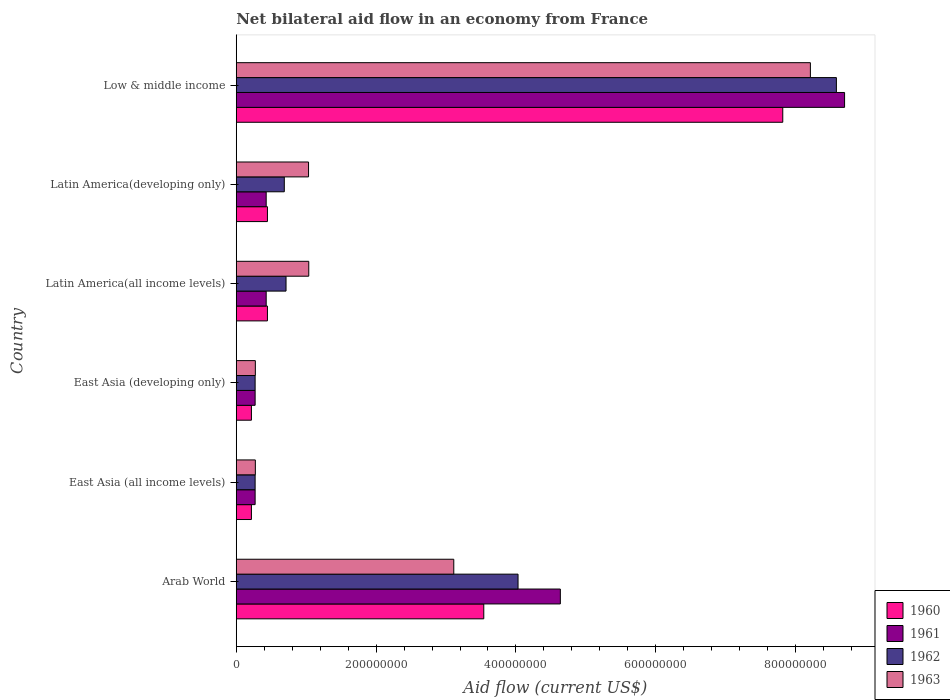How many different coloured bars are there?
Provide a short and direct response. 4. Are the number of bars per tick equal to the number of legend labels?
Provide a succinct answer. Yes. How many bars are there on the 6th tick from the bottom?
Offer a very short reply. 4. What is the label of the 5th group of bars from the top?
Give a very brief answer. East Asia (all income levels). What is the net bilateral aid flow in 1963 in Arab World?
Provide a short and direct response. 3.11e+08. Across all countries, what is the maximum net bilateral aid flow in 1961?
Keep it short and to the point. 8.70e+08. Across all countries, what is the minimum net bilateral aid flow in 1963?
Offer a very short reply. 2.73e+07. In which country was the net bilateral aid flow in 1963 minimum?
Provide a short and direct response. East Asia (all income levels). What is the total net bilateral aid flow in 1963 in the graph?
Your answer should be compact. 1.39e+09. What is the difference between the net bilateral aid flow in 1963 in Latin America(all income levels) and that in Latin America(developing only)?
Your answer should be very brief. 3.00e+05. What is the difference between the net bilateral aid flow in 1961 in Latin America(all income levels) and the net bilateral aid flow in 1960 in East Asia (all income levels)?
Your answer should be compact. 2.11e+07. What is the average net bilateral aid flow in 1962 per country?
Provide a short and direct response. 2.43e+08. What is the difference between the net bilateral aid flow in 1962 and net bilateral aid flow in 1963 in Latin America(developing only)?
Your response must be concise. -3.47e+07. In how many countries, is the net bilateral aid flow in 1961 greater than 520000000 US$?
Provide a short and direct response. 1. What is the ratio of the net bilateral aid flow in 1962 in East Asia (all income levels) to that in Latin America(developing only)?
Offer a terse response. 0.39. What is the difference between the highest and the second highest net bilateral aid flow in 1963?
Your response must be concise. 5.10e+08. What is the difference between the highest and the lowest net bilateral aid flow in 1963?
Offer a terse response. 7.94e+08. Is the sum of the net bilateral aid flow in 1961 in Latin America(developing only) and Low & middle income greater than the maximum net bilateral aid flow in 1960 across all countries?
Your response must be concise. Yes. What does the 3rd bar from the top in Arab World represents?
Provide a short and direct response. 1961. Is it the case that in every country, the sum of the net bilateral aid flow in 1960 and net bilateral aid flow in 1963 is greater than the net bilateral aid flow in 1962?
Offer a terse response. Yes. What is the difference between two consecutive major ticks on the X-axis?
Provide a succinct answer. 2.00e+08. Does the graph contain grids?
Your response must be concise. No. What is the title of the graph?
Your response must be concise. Net bilateral aid flow in an economy from France. Does "1966" appear as one of the legend labels in the graph?
Provide a succinct answer. No. What is the label or title of the Y-axis?
Your answer should be very brief. Country. What is the Aid flow (current US$) of 1960 in Arab World?
Give a very brief answer. 3.54e+08. What is the Aid flow (current US$) in 1961 in Arab World?
Keep it short and to the point. 4.64e+08. What is the Aid flow (current US$) in 1962 in Arab World?
Ensure brevity in your answer.  4.03e+08. What is the Aid flow (current US$) of 1963 in Arab World?
Offer a very short reply. 3.11e+08. What is the Aid flow (current US$) of 1960 in East Asia (all income levels)?
Give a very brief answer. 2.17e+07. What is the Aid flow (current US$) of 1961 in East Asia (all income levels)?
Give a very brief answer. 2.70e+07. What is the Aid flow (current US$) of 1962 in East Asia (all income levels)?
Ensure brevity in your answer.  2.70e+07. What is the Aid flow (current US$) of 1963 in East Asia (all income levels)?
Ensure brevity in your answer.  2.73e+07. What is the Aid flow (current US$) in 1960 in East Asia (developing only)?
Offer a terse response. 2.17e+07. What is the Aid flow (current US$) in 1961 in East Asia (developing only)?
Give a very brief answer. 2.70e+07. What is the Aid flow (current US$) of 1962 in East Asia (developing only)?
Your response must be concise. 2.70e+07. What is the Aid flow (current US$) of 1963 in East Asia (developing only)?
Ensure brevity in your answer.  2.73e+07. What is the Aid flow (current US$) in 1960 in Latin America(all income levels)?
Give a very brief answer. 4.46e+07. What is the Aid flow (current US$) in 1961 in Latin America(all income levels)?
Your response must be concise. 4.28e+07. What is the Aid flow (current US$) in 1962 in Latin America(all income levels)?
Keep it short and to the point. 7.12e+07. What is the Aid flow (current US$) of 1963 in Latin America(all income levels)?
Your answer should be compact. 1.04e+08. What is the Aid flow (current US$) of 1960 in Latin America(developing only)?
Your response must be concise. 4.46e+07. What is the Aid flow (current US$) of 1961 in Latin America(developing only)?
Provide a short and direct response. 4.28e+07. What is the Aid flow (current US$) in 1962 in Latin America(developing only)?
Provide a succinct answer. 6.87e+07. What is the Aid flow (current US$) in 1963 in Latin America(developing only)?
Offer a very short reply. 1.03e+08. What is the Aid flow (current US$) in 1960 in Low & middle income?
Your answer should be very brief. 7.82e+08. What is the Aid flow (current US$) of 1961 in Low & middle income?
Provide a succinct answer. 8.70e+08. What is the Aid flow (current US$) of 1962 in Low & middle income?
Make the answer very short. 8.58e+08. What is the Aid flow (current US$) of 1963 in Low & middle income?
Ensure brevity in your answer.  8.21e+08. Across all countries, what is the maximum Aid flow (current US$) of 1960?
Keep it short and to the point. 7.82e+08. Across all countries, what is the maximum Aid flow (current US$) in 1961?
Make the answer very short. 8.70e+08. Across all countries, what is the maximum Aid flow (current US$) in 1962?
Your response must be concise. 8.58e+08. Across all countries, what is the maximum Aid flow (current US$) in 1963?
Provide a succinct answer. 8.21e+08. Across all countries, what is the minimum Aid flow (current US$) of 1960?
Offer a very short reply. 2.17e+07. Across all countries, what is the minimum Aid flow (current US$) of 1961?
Your answer should be compact. 2.70e+07. Across all countries, what is the minimum Aid flow (current US$) in 1962?
Give a very brief answer. 2.70e+07. Across all countries, what is the minimum Aid flow (current US$) in 1963?
Provide a succinct answer. 2.73e+07. What is the total Aid flow (current US$) of 1960 in the graph?
Your answer should be very brief. 1.27e+09. What is the total Aid flow (current US$) in 1961 in the graph?
Offer a terse response. 1.47e+09. What is the total Aid flow (current US$) of 1962 in the graph?
Give a very brief answer. 1.46e+09. What is the total Aid flow (current US$) in 1963 in the graph?
Offer a very short reply. 1.39e+09. What is the difference between the Aid flow (current US$) in 1960 in Arab World and that in East Asia (all income levels)?
Offer a terse response. 3.32e+08. What is the difference between the Aid flow (current US$) in 1961 in Arab World and that in East Asia (all income levels)?
Provide a succinct answer. 4.36e+08. What is the difference between the Aid flow (current US$) in 1962 in Arab World and that in East Asia (all income levels)?
Offer a very short reply. 3.76e+08. What is the difference between the Aid flow (current US$) of 1963 in Arab World and that in East Asia (all income levels)?
Your answer should be compact. 2.84e+08. What is the difference between the Aid flow (current US$) of 1960 in Arab World and that in East Asia (developing only)?
Give a very brief answer. 3.32e+08. What is the difference between the Aid flow (current US$) in 1961 in Arab World and that in East Asia (developing only)?
Offer a very short reply. 4.36e+08. What is the difference between the Aid flow (current US$) of 1962 in Arab World and that in East Asia (developing only)?
Your answer should be very brief. 3.76e+08. What is the difference between the Aid flow (current US$) in 1963 in Arab World and that in East Asia (developing only)?
Ensure brevity in your answer.  2.84e+08. What is the difference between the Aid flow (current US$) in 1960 in Arab World and that in Latin America(all income levels)?
Your answer should be compact. 3.09e+08. What is the difference between the Aid flow (current US$) of 1961 in Arab World and that in Latin America(all income levels)?
Offer a very short reply. 4.21e+08. What is the difference between the Aid flow (current US$) in 1962 in Arab World and that in Latin America(all income levels)?
Your answer should be very brief. 3.32e+08. What is the difference between the Aid flow (current US$) of 1963 in Arab World and that in Latin America(all income levels)?
Make the answer very short. 2.07e+08. What is the difference between the Aid flow (current US$) of 1960 in Arab World and that in Latin America(developing only)?
Your response must be concise. 3.09e+08. What is the difference between the Aid flow (current US$) in 1961 in Arab World and that in Latin America(developing only)?
Make the answer very short. 4.21e+08. What is the difference between the Aid flow (current US$) of 1962 in Arab World and that in Latin America(developing only)?
Provide a short and direct response. 3.34e+08. What is the difference between the Aid flow (current US$) in 1963 in Arab World and that in Latin America(developing only)?
Provide a short and direct response. 2.08e+08. What is the difference between the Aid flow (current US$) of 1960 in Arab World and that in Low & middle income?
Give a very brief answer. -4.28e+08. What is the difference between the Aid flow (current US$) of 1961 in Arab World and that in Low & middle income?
Your answer should be very brief. -4.06e+08. What is the difference between the Aid flow (current US$) of 1962 in Arab World and that in Low & middle income?
Your response must be concise. -4.55e+08. What is the difference between the Aid flow (current US$) of 1963 in Arab World and that in Low & middle income?
Make the answer very short. -5.10e+08. What is the difference between the Aid flow (current US$) of 1961 in East Asia (all income levels) and that in East Asia (developing only)?
Ensure brevity in your answer.  0. What is the difference between the Aid flow (current US$) of 1962 in East Asia (all income levels) and that in East Asia (developing only)?
Make the answer very short. 0. What is the difference between the Aid flow (current US$) of 1960 in East Asia (all income levels) and that in Latin America(all income levels)?
Ensure brevity in your answer.  -2.29e+07. What is the difference between the Aid flow (current US$) of 1961 in East Asia (all income levels) and that in Latin America(all income levels)?
Offer a very short reply. -1.58e+07. What is the difference between the Aid flow (current US$) in 1962 in East Asia (all income levels) and that in Latin America(all income levels)?
Provide a short and direct response. -4.42e+07. What is the difference between the Aid flow (current US$) of 1963 in East Asia (all income levels) and that in Latin America(all income levels)?
Ensure brevity in your answer.  -7.64e+07. What is the difference between the Aid flow (current US$) in 1960 in East Asia (all income levels) and that in Latin America(developing only)?
Give a very brief answer. -2.29e+07. What is the difference between the Aid flow (current US$) in 1961 in East Asia (all income levels) and that in Latin America(developing only)?
Make the answer very short. -1.58e+07. What is the difference between the Aid flow (current US$) of 1962 in East Asia (all income levels) and that in Latin America(developing only)?
Ensure brevity in your answer.  -4.17e+07. What is the difference between the Aid flow (current US$) of 1963 in East Asia (all income levels) and that in Latin America(developing only)?
Provide a short and direct response. -7.61e+07. What is the difference between the Aid flow (current US$) in 1960 in East Asia (all income levels) and that in Low & middle income?
Your response must be concise. -7.60e+08. What is the difference between the Aid flow (current US$) in 1961 in East Asia (all income levels) and that in Low & middle income?
Your answer should be very brief. -8.43e+08. What is the difference between the Aid flow (current US$) in 1962 in East Asia (all income levels) and that in Low & middle income?
Give a very brief answer. -8.31e+08. What is the difference between the Aid flow (current US$) of 1963 in East Asia (all income levels) and that in Low & middle income?
Provide a short and direct response. -7.94e+08. What is the difference between the Aid flow (current US$) in 1960 in East Asia (developing only) and that in Latin America(all income levels)?
Your answer should be very brief. -2.29e+07. What is the difference between the Aid flow (current US$) of 1961 in East Asia (developing only) and that in Latin America(all income levels)?
Make the answer very short. -1.58e+07. What is the difference between the Aid flow (current US$) of 1962 in East Asia (developing only) and that in Latin America(all income levels)?
Offer a terse response. -4.42e+07. What is the difference between the Aid flow (current US$) in 1963 in East Asia (developing only) and that in Latin America(all income levels)?
Your answer should be very brief. -7.64e+07. What is the difference between the Aid flow (current US$) in 1960 in East Asia (developing only) and that in Latin America(developing only)?
Provide a succinct answer. -2.29e+07. What is the difference between the Aid flow (current US$) in 1961 in East Asia (developing only) and that in Latin America(developing only)?
Provide a short and direct response. -1.58e+07. What is the difference between the Aid flow (current US$) in 1962 in East Asia (developing only) and that in Latin America(developing only)?
Ensure brevity in your answer.  -4.17e+07. What is the difference between the Aid flow (current US$) in 1963 in East Asia (developing only) and that in Latin America(developing only)?
Your answer should be very brief. -7.61e+07. What is the difference between the Aid flow (current US$) of 1960 in East Asia (developing only) and that in Low & middle income?
Keep it short and to the point. -7.60e+08. What is the difference between the Aid flow (current US$) of 1961 in East Asia (developing only) and that in Low & middle income?
Offer a terse response. -8.43e+08. What is the difference between the Aid flow (current US$) in 1962 in East Asia (developing only) and that in Low & middle income?
Your answer should be very brief. -8.31e+08. What is the difference between the Aid flow (current US$) of 1963 in East Asia (developing only) and that in Low & middle income?
Make the answer very short. -7.94e+08. What is the difference between the Aid flow (current US$) of 1960 in Latin America(all income levels) and that in Latin America(developing only)?
Your answer should be very brief. 0. What is the difference between the Aid flow (current US$) of 1962 in Latin America(all income levels) and that in Latin America(developing only)?
Provide a short and direct response. 2.50e+06. What is the difference between the Aid flow (current US$) in 1960 in Latin America(all income levels) and that in Low & middle income?
Ensure brevity in your answer.  -7.37e+08. What is the difference between the Aid flow (current US$) in 1961 in Latin America(all income levels) and that in Low & middle income?
Your answer should be very brief. -8.27e+08. What is the difference between the Aid flow (current US$) of 1962 in Latin America(all income levels) and that in Low & middle income?
Offer a very short reply. -7.87e+08. What is the difference between the Aid flow (current US$) of 1963 in Latin America(all income levels) and that in Low & middle income?
Give a very brief answer. -7.17e+08. What is the difference between the Aid flow (current US$) in 1960 in Latin America(developing only) and that in Low & middle income?
Your response must be concise. -7.37e+08. What is the difference between the Aid flow (current US$) in 1961 in Latin America(developing only) and that in Low & middle income?
Offer a terse response. -8.27e+08. What is the difference between the Aid flow (current US$) of 1962 in Latin America(developing only) and that in Low & middle income?
Make the answer very short. -7.90e+08. What is the difference between the Aid flow (current US$) of 1963 in Latin America(developing only) and that in Low & middle income?
Offer a terse response. -7.18e+08. What is the difference between the Aid flow (current US$) in 1960 in Arab World and the Aid flow (current US$) in 1961 in East Asia (all income levels)?
Make the answer very short. 3.27e+08. What is the difference between the Aid flow (current US$) of 1960 in Arab World and the Aid flow (current US$) of 1962 in East Asia (all income levels)?
Offer a terse response. 3.27e+08. What is the difference between the Aid flow (current US$) in 1960 in Arab World and the Aid flow (current US$) in 1963 in East Asia (all income levels)?
Offer a terse response. 3.27e+08. What is the difference between the Aid flow (current US$) in 1961 in Arab World and the Aid flow (current US$) in 1962 in East Asia (all income levels)?
Your response must be concise. 4.36e+08. What is the difference between the Aid flow (current US$) in 1961 in Arab World and the Aid flow (current US$) in 1963 in East Asia (all income levels)?
Your response must be concise. 4.36e+08. What is the difference between the Aid flow (current US$) in 1962 in Arab World and the Aid flow (current US$) in 1963 in East Asia (all income levels)?
Your response must be concise. 3.76e+08. What is the difference between the Aid flow (current US$) of 1960 in Arab World and the Aid flow (current US$) of 1961 in East Asia (developing only)?
Provide a short and direct response. 3.27e+08. What is the difference between the Aid flow (current US$) in 1960 in Arab World and the Aid flow (current US$) in 1962 in East Asia (developing only)?
Provide a short and direct response. 3.27e+08. What is the difference between the Aid flow (current US$) of 1960 in Arab World and the Aid flow (current US$) of 1963 in East Asia (developing only)?
Give a very brief answer. 3.27e+08. What is the difference between the Aid flow (current US$) in 1961 in Arab World and the Aid flow (current US$) in 1962 in East Asia (developing only)?
Offer a terse response. 4.36e+08. What is the difference between the Aid flow (current US$) of 1961 in Arab World and the Aid flow (current US$) of 1963 in East Asia (developing only)?
Offer a terse response. 4.36e+08. What is the difference between the Aid flow (current US$) of 1962 in Arab World and the Aid flow (current US$) of 1963 in East Asia (developing only)?
Provide a succinct answer. 3.76e+08. What is the difference between the Aid flow (current US$) of 1960 in Arab World and the Aid flow (current US$) of 1961 in Latin America(all income levels)?
Provide a succinct answer. 3.11e+08. What is the difference between the Aid flow (current US$) in 1960 in Arab World and the Aid flow (current US$) in 1962 in Latin America(all income levels)?
Ensure brevity in your answer.  2.83e+08. What is the difference between the Aid flow (current US$) of 1960 in Arab World and the Aid flow (current US$) of 1963 in Latin America(all income levels)?
Ensure brevity in your answer.  2.50e+08. What is the difference between the Aid flow (current US$) in 1961 in Arab World and the Aid flow (current US$) in 1962 in Latin America(all income levels)?
Make the answer very short. 3.92e+08. What is the difference between the Aid flow (current US$) of 1961 in Arab World and the Aid flow (current US$) of 1963 in Latin America(all income levels)?
Offer a very short reply. 3.60e+08. What is the difference between the Aid flow (current US$) of 1962 in Arab World and the Aid flow (current US$) of 1963 in Latin America(all income levels)?
Your answer should be very brief. 2.99e+08. What is the difference between the Aid flow (current US$) in 1960 in Arab World and the Aid flow (current US$) in 1961 in Latin America(developing only)?
Your response must be concise. 3.11e+08. What is the difference between the Aid flow (current US$) in 1960 in Arab World and the Aid flow (current US$) in 1962 in Latin America(developing only)?
Give a very brief answer. 2.85e+08. What is the difference between the Aid flow (current US$) in 1960 in Arab World and the Aid flow (current US$) in 1963 in Latin America(developing only)?
Your answer should be compact. 2.51e+08. What is the difference between the Aid flow (current US$) in 1961 in Arab World and the Aid flow (current US$) in 1962 in Latin America(developing only)?
Your response must be concise. 3.95e+08. What is the difference between the Aid flow (current US$) in 1961 in Arab World and the Aid flow (current US$) in 1963 in Latin America(developing only)?
Keep it short and to the point. 3.60e+08. What is the difference between the Aid flow (current US$) of 1962 in Arab World and the Aid flow (current US$) of 1963 in Latin America(developing only)?
Ensure brevity in your answer.  3.00e+08. What is the difference between the Aid flow (current US$) of 1960 in Arab World and the Aid flow (current US$) of 1961 in Low & middle income?
Keep it short and to the point. -5.16e+08. What is the difference between the Aid flow (current US$) in 1960 in Arab World and the Aid flow (current US$) in 1962 in Low & middle income?
Your response must be concise. -5.04e+08. What is the difference between the Aid flow (current US$) in 1960 in Arab World and the Aid flow (current US$) in 1963 in Low & middle income?
Your answer should be compact. -4.67e+08. What is the difference between the Aid flow (current US$) of 1961 in Arab World and the Aid flow (current US$) of 1962 in Low & middle income?
Give a very brief answer. -3.95e+08. What is the difference between the Aid flow (current US$) of 1961 in Arab World and the Aid flow (current US$) of 1963 in Low & middle income?
Keep it short and to the point. -3.58e+08. What is the difference between the Aid flow (current US$) of 1962 in Arab World and the Aid flow (current US$) of 1963 in Low & middle income?
Provide a succinct answer. -4.18e+08. What is the difference between the Aid flow (current US$) in 1960 in East Asia (all income levels) and the Aid flow (current US$) in 1961 in East Asia (developing only)?
Ensure brevity in your answer.  -5.30e+06. What is the difference between the Aid flow (current US$) of 1960 in East Asia (all income levels) and the Aid flow (current US$) of 1962 in East Asia (developing only)?
Ensure brevity in your answer.  -5.30e+06. What is the difference between the Aid flow (current US$) of 1960 in East Asia (all income levels) and the Aid flow (current US$) of 1963 in East Asia (developing only)?
Keep it short and to the point. -5.60e+06. What is the difference between the Aid flow (current US$) in 1962 in East Asia (all income levels) and the Aid flow (current US$) in 1963 in East Asia (developing only)?
Keep it short and to the point. -3.00e+05. What is the difference between the Aid flow (current US$) in 1960 in East Asia (all income levels) and the Aid flow (current US$) in 1961 in Latin America(all income levels)?
Your answer should be very brief. -2.11e+07. What is the difference between the Aid flow (current US$) in 1960 in East Asia (all income levels) and the Aid flow (current US$) in 1962 in Latin America(all income levels)?
Your response must be concise. -4.95e+07. What is the difference between the Aid flow (current US$) in 1960 in East Asia (all income levels) and the Aid flow (current US$) in 1963 in Latin America(all income levels)?
Ensure brevity in your answer.  -8.20e+07. What is the difference between the Aid flow (current US$) in 1961 in East Asia (all income levels) and the Aid flow (current US$) in 1962 in Latin America(all income levels)?
Ensure brevity in your answer.  -4.42e+07. What is the difference between the Aid flow (current US$) in 1961 in East Asia (all income levels) and the Aid flow (current US$) in 1963 in Latin America(all income levels)?
Ensure brevity in your answer.  -7.67e+07. What is the difference between the Aid flow (current US$) of 1962 in East Asia (all income levels) and the Aid flow (current US$) of 1963 in Latin America(all income levels)?
Make the answer very short. -7.67e+07. What is the difference between the Aid flow (current US$) of 1960 in East Asia (all income levels) and the Aid flow (current US$) of 1961 in Latin America(developing only)?
Ensure brevity in your answer.  -2.11e+07. What is the difference between the Aid flow (current US$) of 1960 in East Asia (all income levels) and the Aid flow (current US$) of 1962 in Latin America(developing only)?
Your answer should be very brief. -4.70e+07. What is the difference between the Aid flow (current US$) of 1960 in East Asia (all income levels) and the Aid flow (current US$) of 1963 in Latin America(developing only)?
Your response must be concise. -8.17e+07. What is the difference between the Aid flow (current US$) in 1961 in East Asia (all income levels) and the Aid flow (current US$) in 1962 in Latin America(developing only)?
Keep it short and to the point. -4.17e+07. What is the difference between the Aid flow (current US$) in 1961 in East Asia (all income levels) and the Aid flow (current US$) in 1963 in Latin America(developing only)?
Keep it short and to the point. -7.64e+07. What is the difference between the Aid flow (current US$) in 1962 in East Asia (all income levels) and the Aid flow (current US$) in 1963 in Latin America(developing only)?
Give a very brief answer. -7.64e+07. What is the difference between the Aid flow (current US$) in 1960 in East Asia (all income levels) and the Aid flow (current US$) in 1961 in Low & middle income?
Provide a succinct answer. -8.48e+08. What is the difference between the Aid flow (current US$) in 1960 in East Asia (all income levels) and the Aid flow (current US$) in 1962 in Low & middle income?
Offer a very short reply. -8.37e+08. What is the difference between the Aid flow (current US$) of 1960 in East Asia (all income levels) and the Aid flow (current US$) of 1963 in Low & middle income?
Ensure brevity in your answer.  -7.99e+08. What is the difference between the Aid flow (current US$) in 1961 in East Asia (all income levels) and the Aid flow (current US$) in 1962 in Low & middle income?
Your response must be concise. -8.31e+08. What is the difference between the Aid flow (current US$) in 1961 in East Asia (all income levels) and the Aid flow (current US$) in 1963 in Low & middle income?
Your response must be concise. -7.94e+08. What is the difference between the Aid flow (current US$) of 1962 in East Asia (all income levels) and the Aid flow (current US$) of 1963 in Low & middle income?
Offer a very short reply. -7.94e+08. What is the difference between the Aid flow (current US$) of 1960 in East Asia (developing only) and the Aid flow (current US$) of 1961 in Latin America(all income levels)?
Make the answer very short. -2.11e+07. What is the difference between the Aid flow (current US$) in 1960 in East Asia (developing only) and the Aid flow (current US$) in 1962 in Latin America(all income levels)?
Provide a short and direct response. -4.95e+07. What is the difference between the Aid flow (current US$) of 1960 in East Asia (developing only) and the Aid flow (current US$) of 1963 in Latin America(all income levels)?
Offer a very short reply. -8.20e+07. What is the difference between the Aid flow (current US$) of 1961 in East Asia (developing only) and the Aid flow (current US$) of 1962 in Latin America(all income levels)?
Offer a terse response. -4.42e+07. What is the difference between the Aid flow (current US$) in 1961 in East Asia (developing only) and the Aid flow (current US$) in 1963 in Latin America(all income levels)?
Your response must be concise. -7.67e+07. What is the difference between the Aid flow (current US$) in 1962 in East Asia (developing only) and the Aid flow (current US$) in 1963 in Latin America(all income levels)?
Provide a succinct answer. -7.67e+07. What is the difference between the Aid flow (current US$) in 1960 in East Asia (developing only) and the Aid flow (current US$) in 1961 in Latin America(developing only)?
Your answer should be very brief. -2.11e+07. What is the difference between the Aid flow (current US$) of 1960 in East Asia (developing only) and the Aid flow (current US$) of 1962 in Latin America(developing only)?
Provide a short and direct response. -4.70e+07. What is the difference between the Aid flow (current US$) in 1960 in East Asia (developing only) and the Aid flow (current US$) in 1963 in Latin America(developing only)?
Provide a short and direct response. -8.17e+07. What is the difference between the Aid flow (current US$) in 1961 in East Asia (developing only) and the Aid flow (current US$) in 1962 in Latin America(developing only)?
Provide a succinct answer. -4.17e+07. What is the difference between the Aid flow (current US$) in 1961 in East Asia (developing only) and the Aid flow (current US$) in 1963 in Latin America(developing only)?
Give a very brief answer. -7.64e+07. What is the difference between the Aid flow (current US$) of 1962 in East Asia (developing only) and the Aid flow (current US$) of 1963 in Latin America(developing only)?
Your answer should be compact. -7.64e+07. What is the difference between the Aid flow (current US$) in 1960 in East Asia (developing only) and the Aid flow (current US$) in 1961 in Low & middle income?
Provide a succinct answer. -8.48e+08. What is the difference between the Aid flow (current US$) of 1960 in East Asia (developing only) and the Aid flow (current US$) of 1962 in Low & middle income?
Offer a very short reply. -8.37e+08. What is the difference between the Aid flow (current US$) in 1960 in East Asia (developing only) and the Aid flow (current US$) in 1963 in Low & middle income?
Provide a short and direct response. -7.99e+08. What is the difference between the Aid flow (current US$) in 1961 in East Asia (developing only) and the Aid flow (current US$) in 1962 in Low & middle income?
Offer a terse response. -8.31e+08. What is the difference between the Aid flow (current US$) of 1961 in East Asia (developing only) and the Aid flow (current US$) of 1963 in Low & middle income?
Give a very brief answer. -7.94e+08. What is the difference between the Aid flow (current US$) in 1962 in East Asia (developing only) and the Aid flow (current US$) in 1963 in Low & middle income?
Make the answer very short. -7.94e+08. What is the difference between the Aid flow (current US$) of 1960 in Latin America(all income levels) and the Aid flow (current US$) of 1961 in Latin America(developing only)?
Give a very brief answer. 1.80e+06. What is the difference between the Aid flow (current US$) of 1960 in Latin America(all income levels) and the Aid flow (current US$) of 1962 in Latin America(developing only)?
Give a very brief answer. -2.41e+07. What is the difference between the Aid flow (current US$) of 1960 in Latin America(all income levels) and the Aid flow (current US$) of 1963 in Latin America(developing only)?
Offer a terse response. -5.88e+07. What is the difference between the Aid flow (current US$) of 1961 in Latin America(all income levels) and the Aid flow (current US$) of 1962 in Latin America(developing only)?
Offer a terse response. -2.59e+07. What is the difference between the Aid flow (current US$) in 1961 in Latin America(all income levels) and the Aid flow (current US$) in 1963 in Latin America(developing only)?
Your response must be concise. -6.06e+07. What is the difference between the Aid flow (current US$) of 1962 in Latin America(all income levels) and the Aid flow (current US$) of 1963 in Latin America(developing only)?
Ensure brevity in your answer.  -3.22e+07. What is the difference between the Aid flow (current US$) in 1960 in Latin America(all income levels) and the Aid flow (current US$) in 1961 in Low & middle income?
Keep it short and to the point. -8.25e+08. What is the difference between the Aid flow (current US$) of 1960 in Latin America(all income levels) and the Aid flow (current US$) of 1962 in Low & middle income?
Keep it short and to the point. -8.14e+08. What is the difference between the Aid flow (current US$) of 1960 in Latin America(all income levels) and the Aid flow (current US$) of 1963 in Low & middle income?
Provide a succinct answer. -7.76e+08. What is the difference between the Aid flow (current US$) in 1961 in Latin America(all income levels) and the Aid flow (current US$) in 1962 in Low & middle income?
Your answer should be compact. -8.16e+08. What is the difference between the Aid flow (current US$) of 1961 in Latin America(all income levels) and the Aid flow (current US$) of 1963 in Low & middle income?
Make the answer very short. -7.78e+08. What is the difference between the Aid flow (current US$) of 1962 in Latin America(all income levels) and the Aid flow (current US$) of 1963 in Low & middle income?
Provide a succinct answer. -7.50e+08. What is the difference between the Aid flow (current US$) of 1960 in Latin America(developing only) and the Aid flow (current US$) of 1961 in Low & middle income?
Provide a succinct answer. -8.25e+08. What is the difference between the Aid flow (current US$) in 1960 in Latin America(developing only) and the Aid flow (current US$) in 1962 in Low & middle income?
Keep it short and to the point. -8.14e+08. What is the difference between the Aid flow (current US$) of 1960 in Latin America(developing only) and the Aid flow (current US$) of 1963 in Low & middle income?
Offer a very short reply. -7.76e+08. What is the difference between the Aid flow (current US$) of 1961 in Latin America(developing only) and the Aid flow (current US$) of 1962 in Low & middle income?
Provide a succinct answer. -8.16e+08. What is the difference between the Aid flow (current US$) of 1961 in Latin America(developing only) and the Aid flow (current US$) of 1963 in Low & middle income?
Offer a very short reply. -7.78e+08. What is the difference between the Aid flow (current US$) of 1962 in Latin America(developing only) and the Aid flow (current US$) of 1963 in Low & middle income?
Your response must be concise. -7.52e+08. What is the average Aid flow (current US$) of 1960 per country?
Your response must be concise. 2.11e+08. What is the average Aid flow (current US$) of 1961 per country?
Your answer should be compact. 2.46e+08. What is the average Aid flow (current US$) of 1962 per country?
Ensure brevity in your answer.  2.43e+08. What is the average Aid flow (current US$) of 1963 per country?
Make the answer very short. 2.32e+08. What is the difference between the Aid flow (current US$) in 1960 and Aid flow (current US$) in 1961 in Arab World?
Your response must be concise. -1.10e+08. What is the difference between the Aid flow (current US$) in 1960 and Aid flow (current US$) in 1962 in Arab World?
Provide a succinct answer. -4.90e+07. What is the difference between the Aid flow (current US$) of 1960 and Aid flow (current US$) of 1963 in Arab World?
Your answer should be very brief. 4.29e+07. What is the difference between the Aid flow (current US$) in 1961 and Aid flow (current US$) in 1962 in Arab World?
Ensure brevity in your answer.  6.05e+07. What is the difference between the Aid flow (current US$) in 1961 and Aid flow (current US$) in 1963 in Arab World?
Make the answer very short. 1.52e+08. What is the difference between the Aid flow (current US$) in 1962 and Aid flow (current US$) in 1963 in Arab World?
Your answer should be compact. 9.19e+07. What is the difference between the Aid flow (current US$) of 1960 and Aid flow (current US$) of 1961 in East Asia (all income levels)?
Offer a very short reply. -5.30e+06. What is the difference between the Aid flow (current US$) in 1960 and Aid flow (current US$) in 1962 in East Asia (all income levels)?
Offer a terse response. -5.30e+06. What is the difference between the Aid flow (current US$) in 1960 and Aid flow (current US$) in 1963 in East Asia (all income levels)?
Give a very brief answer. -5.60e+06. What is the difference between the Aid flow (current US$) of 1961 and Aid flow (current US$) of 1962 in East Asia (all income levels)?
Provide a short and direct response. 0. What is the difference between the Aid flow (current US$) in 1961 and Aid flow (current US$) in 1963 in East Asia (all income levels)?
Offer a very short reply. -3.00e+05. What is the difference between the Aid flow (current US$) of 1962 and Aid flow (current US$) of 1963 in East Asia (all income levels)?
Your answer should be very brief. -3.00e+05. What is the difference between the Aid flow (current US$) of 1960 and Aid flow (current US$) of 1961 in East Asia (developing only)?
Your response must be concise. -5.30e+06. What is the difference between the Aid flow (current US$) of 1960 and Aid flow (current US$) of 1962 in East Asia (developing only)?
Offer a terse response. -5.30e+06. What is the difference between the Aid flow (current US$) of 1960 and Aid flow (current US$) of 1963 in East Asia (developing only)?
Your answer should be very brief. -5.60e+06. What is the difference between the Aid flow (current US$) of 1961 and Aid flow (current US$) of 1963 in East Asia (developing only)?
Offer a very short reply. -3.00e+05. What is the difference between the Aid flow (current US$) in 1962 and Aid flow (current US$) in 1963 in East Asia (developing only)?
Ensure brevity in your answer.  -3.00e+05. What is the difference between the Aid flow (current US$) in 1960 and Aid flow (current US$) in 1961 in Latin America(all income levels)?
Keep it short and to the point. 1.80e+06. What is the difference between the Aid flow (current US$) in 1960 and Aid flow (current US$) in 1962 in Latin America(all income levels)?
Offer a very short reply. -2.66e+07. What is the difference between the Aid flow (current US$) of 1960 and Aid flow (current US$) of 1963 in Latin America(all income levels)?
Your answer should be very brief. -5.91e+07. What is the difference between the Aid flow (current US$) of 1961 and Aid flow (current US$) of 1962 in Latin America(all income levels)?
Provide a short and direct response. -2.84e+07. What is the difference between the Aid flow (current US$) in 1961 and Aid flow (current US$) in 1963 in Latin America(all income levels)?
Keep it short and to the point. -6.09e+07. What is the difference between the Aid flow (current US$) of 1962 and Aid flow (current US$) of 1963 in Latin America(all income levels)?
Give a very brief answer. -3.25e+07. What is the difference between the Aid flow (current US$) in 1960 and Aid flow (current US$) in 1961 in Latin America(developing only)?
Make the answer very short. 1.80e+06. What is the difference between the Aid flow (current US$) in 1960 and Aid flow (current US$) in 1962 in Latin America(developing only)?
Give a very brief answer. -2.41e+07. What is the difference between the Aid flow (current US$) in 1960 and Aid flow (current US$) in 1963 in Latin America(developing only)?
Ensure brevity in your answer.  -5.88e+07. What is the difference between the Aid flow (current US$) in 1961 and Aid flow (current US$) in 1962 in Latin America(developing only)?
Your answer should be very brief. -2.59e+07. What is the difference between the Aid flow (current US$) of 1961 and Aid flow (current US$) of 1963 in Latin America(developing only)?
Give a very brief answer. -6.06e+07. What is the difference between the Aid flow (current US$) in 1962 and Aid flow (current US$) in 1963 in Latin America(developing only)?
Your answer should be compact. -3.47e+07. What is the difference between the Aid flow (current US$) of 1960 and Aid flow (current US$) of 1961 in Low & middle income?
Your answer should be very brief. -8.84e+07. What is the difference between the Aid flow (current US$) in 1960 and Aid flow (current US$) in 1962 in Low & middle income?
Make the answer very short. -7.67e+07. What is the difference between the Aid flow (current US$) of 1960 and Aid flow (current US$) of 1963 in Low & middle income?
Your answer should be very brief. -3.95e+07. What is the difference between the Aid flow (current US$) in 1961 and Aid flow (current US$) in 1962 in Low & middle income?
Make the answer very short. 1.17e+07. What is the difference between the Aid flow (current US$) in 1961 and Aid flow (current US$) in 1963 in Low & middle income?
Your answer should be very brief. 4.89e+07. What is the difference between the Aid flow (current US$) of 1962 and Aid flow (current US$) of 1963 in Low & middle income?
Your answer should be compact. 3.72e+07. What is the ratio of the Aid flow (current US$) of 1960 in Arab World to that in East Asia (all income levels)?
Provide a succinct answer. 16.31. What is the ratio of the Aid flow (current US$) of 1961 in Arab World to that in East Asia (all income levels)?
Keep it short and to the point. 17.17. What is the ratio of the Aid flow (current US$) in 1962 in Arab World to that in East Asia (all income levels)?
Ensure brevity in your answer.  14.93. What is the ratio of the Aid flow (current US$) of 1963 in Arab World to that in East Asia (all income levels)?
Give a very brief answer. 11.4. What is the ratio of the Aid flow (current US$) of 1960 in Arab World to that in East Asia (developing only)?
Make the answer very short. 16.31. What is the ratio of the Aid flow (current US$) of 1961 in Arab World to that in East Asia (developing only)?
Ensure brevity in your answer.  17.17. What is the ratio of the Aid flow (current US$) of 1962 in Arab World to that in East Asia (developing only)?
Offer a terse response. 14.93. What is the ratio of the Aid flow (current US$) of 1963 in Arab World to that in East Asia (developing only)?
Make the answer very short. 11.4. What is the ratio of the Aid flow (current US$) of 1960 in Arab World to that in Latin America(all income levels)?
Your answer should be very brief. 7.94. What is the ratio of the Aid flow (current US$) of 1961 in Arab World to that in Latin America(all income levels)?
Your answer should be compact. 10.83. What is the ratio of the Aid flow (current US$) of 1962 in Arab World to that in Latin America(all income levels)?
Ensure brevity in your answer.  5.66. What is the ratio of the Aid flow (current US$) in 1963 in Arab World to that in Latin America(all income levels)?
Offer a very short reply. 3. What is the ratio of the Aid flow (current US$) of 1960 in Arab World to that in Latin America(developing only)?
Offer a very short reply. 7.94. What is the ratio of the Aid flow (current US$) in 1961 in Arab World to that in Latin America(developing only)?
Provide a short and direct response. 10.83. What is the ratio of the Aid flow (current US$) in 1962 in Arab World to that in Latin America(developing only)?
Give a very brief answer. 5.87. What is the ratio of the Aid flow (current US$) in 1963 in Arab World to that in Latin America(developing only)?
Your answer should be compact. 3.01. What is the ratio of the Aid flow (current US$) of 1960 in Arab World to that in Low & middle income?
Give a very brief answer. 0.45. What is the ratio of the Aid flow (current US$) in 1961 in Arab World to that in Low & middle income?
Your answer should be very brief. 0.53. What is the ratio of the Aid flow (current US$) in 1962 in Arab World to that in Low & middle income?
Keep it short and to the point. 0.47. What is the ratio of the Aid flow (current US$) in 1963 in Arab World to that in Low & middle income?
Ensure brevity in your answer.  0.38. What is the ratio of the Aid flow (current US$) of 1960 in East Asia (all income levels) to that in East Asia (developing only)?
Ensure brevity in your answer.  1. What is the ratio of the Aid flow (current US$) of 1961 in East Asia (all income levels) to that in East Asia (developing only)?
Give a very brief answer. 1. What is the ratio of the Aid flow (current US$) in 1962 in East Asia (all income levels) to that in East Asia (developing only)?
Offer a terse response. 1. What is the ratio of the Aid flow (current US$) in 1963 in East Asia (all income levels) to that in East Asia (developing only)?
Provide a short and direct response. 1. What is the ratio of the Aid flow (current US$) of 1960 in East Asia (all income levels) to that in Latin America(all income levels)?
Ensure brevity in your answer.  0.49. What is the ratio of the Aid flow (current US$) of 1961 in East Asia (all income levels) to that in Latin America(all income levels)?
Provide a succinct answer. 0.63. What is the ratio of the Aid flow (current US$) in 1962 in East Asia (all income levels) to that in Latin America(all income levels)?
Provide a short and direct response. 0.38. What is the ratio of the Aid flow (current US$) of 1963 in East Asia (all income levels) to that in Latin America(all income levels)?
Provide a short and direct response. 0.26. What is the ratio of the Aid flow (current US$) in 1960 in East Asia (all income levels) to that in Latin America(developing only)?
Make the answer very short. 0.49. What is the ratio of the Aid flow (current US$) of 1961 in East Asia (all income levels) to that in Latin America(developing only)?
Provide a short and direct response. 0.63. What is the ratio of the Aid flow (current US$) of 1962 in East Asia (all income levels) to that in Latin America(developing only)?
Keep it short and to the point. 0.39. What is the ratio of the Aid flow (current US$) of 1963 in East Asia (all income levels) to that in Latin America(developing only)?
Your response must be concise. 0.26. What is the ratio of the Aid flow (current US$) in 1960 in East Asia (all income levels) to that in Low & middle income?
Ensure brevity in your answer.  0.03. What is the ratio of the Aid flow (current US$) of 1961 in East Asia (all income levels) to that in Low & middle income?
Provide a succinct answer. 0.03. What is the ratio of the Aid flow (current US$) of 1962 in East Asia (all income levels) to that in Low & middle income?
Provide a short and direct response. 0.03. What is the ratio of the Aid flow (current US$) in 1963 in East Asia (all income levels) to that in Low & middle income?
Make the answer very short. 0.03. What is the ratio of the Aid flow (current US$) of 1960 in East Asia (developing only) to that in Latin America(all income levels)?
Ensure brevity in your answer.  0.49. What is the ratio of the Aid flow (current US$) in 1961 in East Asia (developing only) to that in Latin America(all income levels)?
Your response must be concise. 0.63. What is the ratio of the Aid flow (current US$) of 1962 in East Asia (developing only) to that in Latin America(all income levels)?
Provide a succinct answer. 0.38. What is the ratio of the Aid flow (current US$) of 1963 in East Asia (developing only) to that in Latin America(all income levels)?
Offer a terse response. 0.26. What is the ratio of the Aid flow (current US$) in 1960 in East Asia (developing only) to that in Latin America(developing only)?
Keep it short and to the point. 0.49. What is the ratio of the Aid flow (current US$) of 1961 in East Asia (developing only) to that in Latin America(developing only)?
Offer a terse response. 0.63. What is the ratio of the Aid flow (current US$) in 1962 in East Asia (developing only) to that in Latin America(developing only)?
Keep it short and to the point. 0.39. What is the ratio of the Aid flow (current US$) in 1963 in East Asia (developing only) to that in Latin America(developing only)?
Give a very brief answer. 0.26. What is the ratio of the Aid flow (current US$) in 1960 in East Asia (developing only) to that in Low & middle income?
Keep it short and to the point. 0.03. What is the ratio of the Aid flow (current US$) in 1961 in East Asia (developing only) to that in Low & middle income?
Make the answer very short. 0.03. What is the ratio of the Aid flow (current US$) of 1962 in East Asia (developing only) to that in Low & middle income?
Provide a succinct answer. 0.03. What is the ratio of the Aid flow (current US$) of 1963 in East Asia (developing only) to that in Low & middle income?
Offer a terse response. 0.03. What is the ratio of the Aid flow (current US$) of 1962 in Latin America(all income levels) to that in Latin America(developing only)?
Give a very brief answer. 1.04. What is the ratio of the Aid flow (current US$) of 1963 in Latin America(all income levels) to that in Latin America(developing only)?
Keep it short and to the point. 1. What is the ratio of the Aid flow (current US$) of 1960 in Latin America(all income levels) to that in Low & middle income?
Your answer should be very brief. 0.06. What is the ratio of the Aid flow (current US$) of 1961 in Latin America(all income levels) to that in Low & middle income?
Provide a succinct answer. 0.05. What is the ratio of the Aid flow (current US$) of 1962 in Latin America(all income levels) to that in Low & middle income?
Ensure brevity in your answer.  0.08. What is the ratio of the Aid flow (current US$) of 1963 in Latin America(all income levels) to that in Low & middle income?
Your answer should be very brief. 0.13. What is the ratio of the Aid flow (current US$) in 1960 in Latin America(developing only) to that in Low & middle income?
Ensure brevity in your answer.  0.06. What is the ratio of the Aid flow (current US$) in 1961 in Latin America(developing only) to that in Low & middle income?
Offer a terse response. 0.05. What is the ratio of the Aid flow (current US$) of 1963 in Latin America(developing only) to that in Low & middle income?
Ensure brevity in your answer.  0.13. What is the difference between the highest and the second highest Aid flow (current US$) of 1960?
Ensure brevity in your answer.  4.28e+08. What is the difference between the highest and the second highest Aid flow (current US$) of 1961?
Your answer should be compact. 4.06e+08. What is the difference between the highest and the second highest Aid flow (current US$) in 1962?
Provide a succinct answer. 4.55e+08. What is the difference between the highest and the second highest Aid flow (current US$) in 1963?
Ensure brevity in your answer.  5.10e+08. What is the difference between the highest and the lowest Aid flow (current US$) in 1960?
Your answer should be very brief. 7.60e+08. What is the difference between the highest and the lowest Aid flow (current US$) in 1961?
Give a very brief answer. 8.43e+08. What is the difference between the highest and the lowest Aid flow (current US$) in 1962?
Offer a very short reply. 8.31e+08. What is the difference between the highest and the lowest Aid flow (current US$) in 1963?
Your answer should be compact. 7.94e+08. 